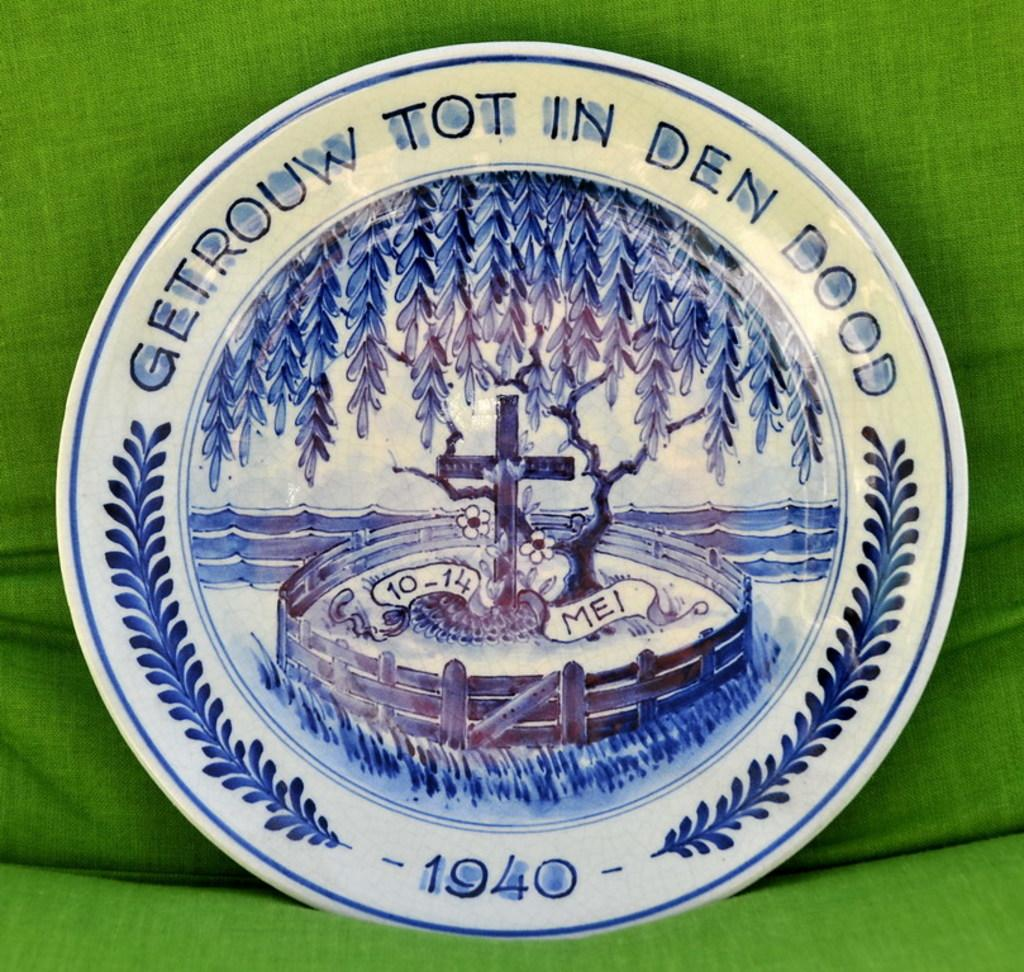What is the color of the object that stands out in the image? The object in the image is white. Can you describe any markings or designs on the white object? The white object has a logo on it. What is the white object placed on in the image? The white object is on a green cloth. How many grapes are on the white object in the image? There are no grapes present in the image. Is there a lawyer standing next to the white object in the image? There is no lawyer present in the image. 